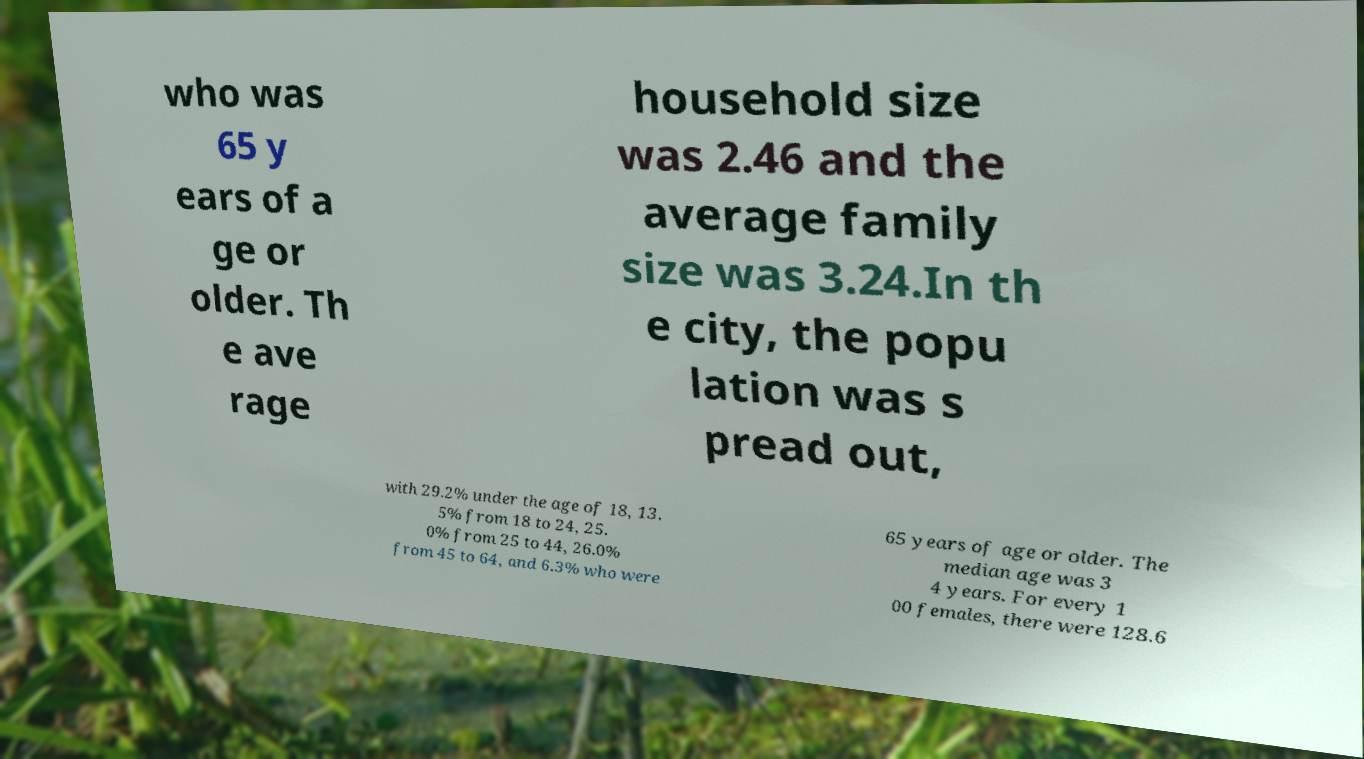What messages or text are displayed in this image? I need them in a readable, typed format. who was 65 y ears of a ge or older. Th e ave rage household size was 2.46 and the average family size was 3.24.In th e city, the popu lation was s pread out, with 29.2% under the age of 18, 13. 5% from 18 to 24, 25. 0% from 25 to 44, 26.0% from 45 to 64, and 6.3% who were 65 years of age or older. The median age was 3 4 years. For every 1 00 females, there were 128.6 